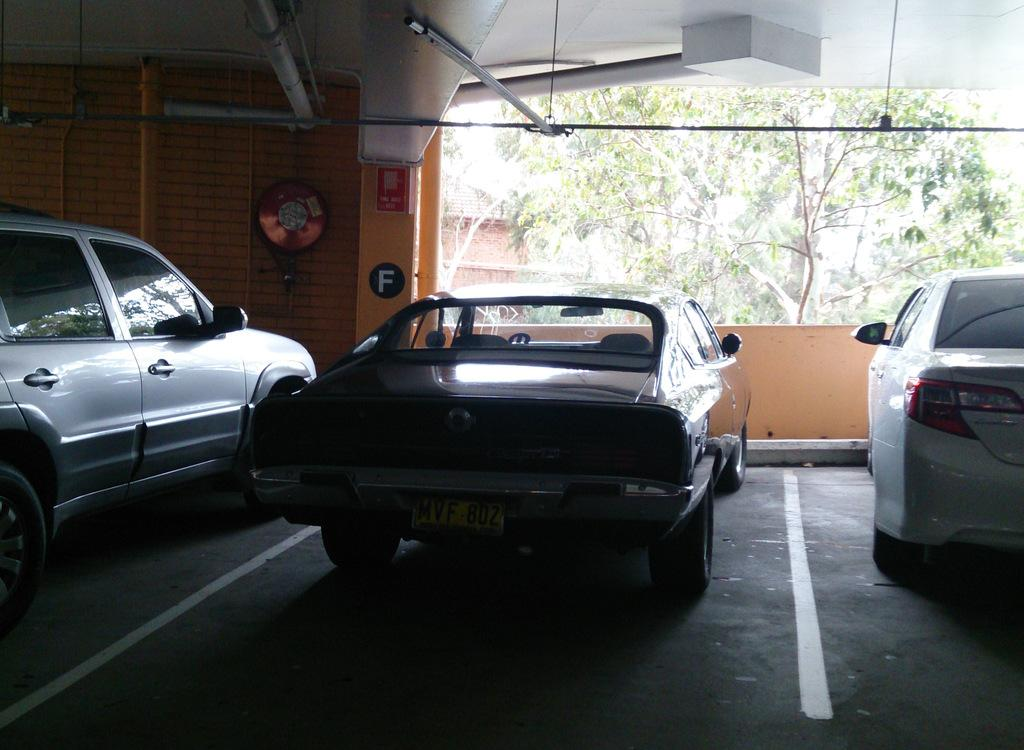What can be seen in the foreground of the image? There are vehicles in the foreground of the image. What is visible in the background of the image? There is a wall, objects, trees, a light, pipes, and rod-like structures in the background of the image. Can you describe the wall in the background? The wall is in the background of the image, but no specific details about the wall are provided in the facts. How many types of structures are visible at the top of the image? There are three types of structures visible at the top of the image: a light, pipes, and rod-like structures. What type of dirt can be seen on the vehicles in the image? There is no mention of dirt on the vehicles in the image, and therefore no such detail can be observed. What time of day is depicted in the image? The time of day is not mentioned in the facts, so it cannot be determined from the image. 